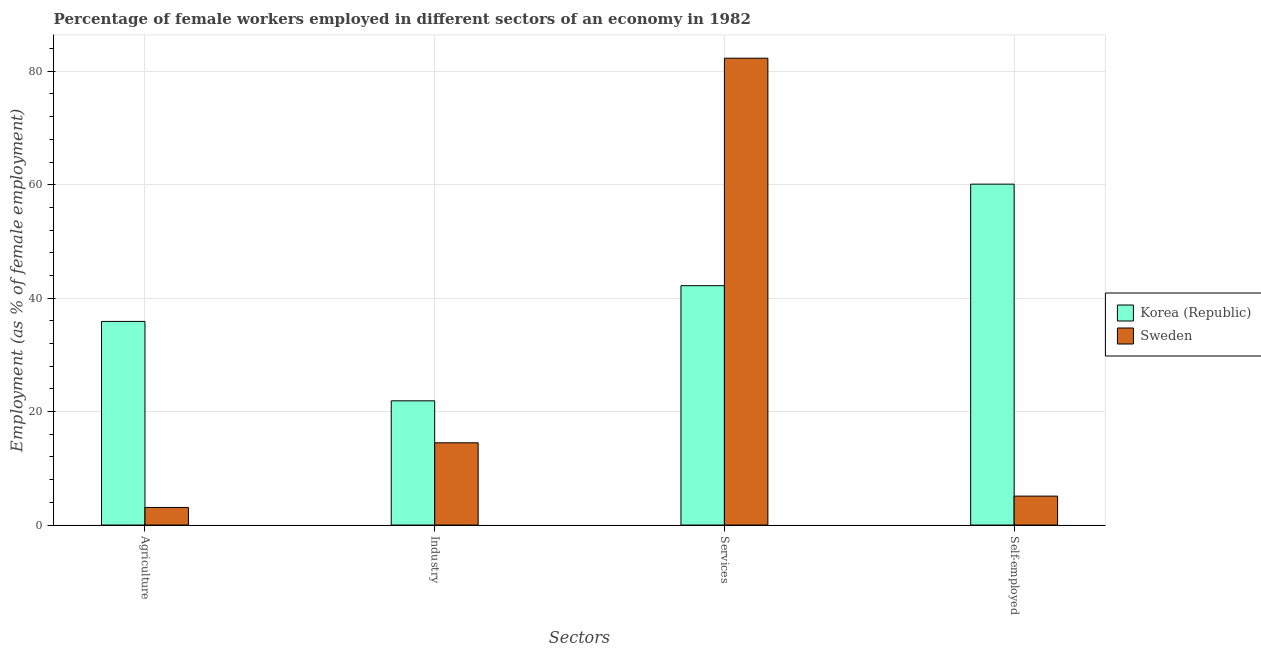How many groups of bars are there?
Provide a short and direct response. 4. Are the number of bars per tick equal to the number of legend labels?
Your answer should be very brief. Yes. Are the number of bars on each tick of the X-axis equal?
Make the answer very short. Yes. How many bars are there on the 2nd tick from the left?
Offer a terse response. 2. What is the label of the 3rd group of bars from the left?
Offer a very short reply. Services. What is the percentage of female workers in agriculture in Sweden?
Give a very brief answer. 3.1. Across all countries, what is the maximum percentage of female workers in services?
Make the answer very short. 82.3. Across all countries, what is the minimum percentage of female workers in services?
Provide a short and direct response. 42.2. What is the total percentage of female workers in services in the graph?
Offer a very short reply. 124.5. What is the difference between the percentage of female workers in industry in Sweden and that in Korea (Republic)?
Keep it short and to the point. -7.4. What is the difference between the percentage of female workers in agriculture in Sweden and the percentage of female workers in services in Korea (Republic)?
Provide a short and direct response. -39.1. What is the average percentage of self employed female workers per country?
Your answer should be very brief. 32.6. What is the difference between the percentage of female workers in services and percentage of female workers in agriculture in Sweden?
Keep it short and to the point. 79.2. What is the ratio of the percentage of female workers in industry in Sweden to that in Korea (Republic)?
Your response must be concise. 0.66. What is the difference between the highest and the second highest percentage of female workers in services?
Ensure brevity in your answer.  40.1. What is the difference between the highest and the lowest percentage of female workers in industry?
Offer a very short reply. 7.4. What does the 2nd bar from the left in Self-employed represents?
Provide a succinct answer. Sweden. Is it the case that in every country, the sum of the percentage of female workers in agriculture and percentage of female workers in industry is greater than the percentage of female workers in services?
Your answer should be very brief. No. How many bars are there?
Provide a short and direct response. 8. What is the difference between two consecutive major ticks on the Y-axis?
Give a very brief answer. 20. Does the graph contain any zero values?
Give a very brief answer. No. Where does the legend appear in the graph?
Make the answer very short. Center right. How are the legend labels stacked?
Provide a short and direct response. Vertical. What is the title of the graph?
Give a very brief answer. Percentage of female workers employed in different sectors of an economy in 1982. What is the label or title of the X-axis?
Your answer should be very brief. Sectors. What is the label or title of the Y-axis?
Offer a terse response. Employment (as % of female employment). What is the Employment (as % of female employment) in Korea (Republic) in Agriculture?
Your answer should be compact. 35.9. What is the Employment (as % of female employment) of Sweden in Agriculture?
Ensure brevity in your answer.  3.1. What is the Employment (as % of female employment) of Korea (Republic) in Industry?
Your response must be concise. 21.9. What is the Employment (as % of female employment) in Sweden in Industry?
Make the answer very short. 14.5. What is the Employment (as % of female employment) in Korea (Republic) in Services?
Keep it short and to the point. 42.2. What is the Employment (as % of female employment) in Sweden in Services?
Your answer should be compact. 82.3. What is the Employment (as % of female employment) of Korea (Republic) in Self-employed?
Offer a very short reply. 60.1. What is the Employment (as % of female employment) of Sweden in Self-employed?
Your answer should be compact. 5.1. Across all Sectors, what is the maximum Employment (as % of female employment) in Korea (Republic)?
Offer a terse response. 60.1. Across all Sectors, what is the maximum Employment (as % of female employment) in Sweden?
Provide a short and direct response. 82.3. Across all Sectors, what is the minimum Employment (as % of female employment) in Korea (Republic)?
Your answer should be compact. 21.9. Across all Sectors, what is the minimum Employment (as % of female employment) in Sweden?
Make the answer very short. 3.1. What is the total Employment (as % of female employment) in Korea (Republic) in the graph?
Your response must be concise. 160.1. What is the total Employment (as % of female employment) in Sweden in the graph?
Provide a short and direct response. 105. What is the difference between the Employment (as % of female employment) of Korea (Republic) in Agriculture and that in Industry?
Keep it short and to the point. 14. What is the difference between the Employment (as % of female employment) in Sweden in Agriculture and that in Industry?
Keep it short and to the point. -11.4. What is the difference between the Employment (as % of female employment) in Sweden in Agriculture and that in Services?
Provide a succinct answer. -79.2. What is the difference between the Employment (as % of female employment) of Korea (Republic) in Agriculture and that in Self-employed?
Offer a terse response. -24.2. What is the difference between the Employment (as % of female employment) of Sweden in Agriculture and that in Self-employed?
Provide a succinct answer. -2. What is the difference between the Employment (as % of female employment) in Korea (Republic) in Industry and that in Services?
Provide a short and direct response. -20.3. What is the difference between the Employment (as % of female employment) in Sweden in Industry and that in Services?
Make the answer very short. -67.8. What is the difference between the Employment (as % of female employment) in Korea (Republic) in Industry and that in Self-employed?
Offer a terse response. -38.2. What is the difference between the Employment (as % of female employment) of Sweden in Industry and that in Self-employed?
Your response must be concise. 9.4. What is the difference between the Employment (as % of female employment) of Korea (Republic) in Services and that in Self-employed?
Give a very brief answer. -17.9. What is the difference between the Employment (as % of female employment) in Sweden in Services and that in Self-employed?
Provide a short and direct response. 77.2. What is the difference between the Employment (as % of female employment) of Korea (Republic) in Agriculture and the Employment (as % of female employment) of Sweden in Industry?
Offer a terse response. 21.4. What is the difference between the Employment (as % of female employment) of Korea (Republic) in Agriculture and the Employment (as % of female employment) of Sweden in Services?
Provide a short and direct response. -46.4. What is the difference between the Employment (as % of female employment) of Korea (Republic) in Agriculture and the Employment (as % of female employment) of Sweden in Self-employed?
Your answer should be compact. 30.8. What is the difference between the Employment (as % of female employment) of Korea (Republic) in Industry and the Employment (as % of female employment) of Sweden in Services?
Keep it short and to the point. -60.4. What is the difference between the Employment (as % of female employment) in Korea (Republic) in Services and the Employment (as % of female employment) in Sweden in Self-employed?
Offer a terse response. 37.1. What is the average Employment (as % of female employment) of Korea (Republic) per Sectors?
Your answer should be very brief. 40.02. What is the average Employment (as % of female employment) in Sweden per Sectors?
Keep it short and to the point. 26.25. What is the difference between the Employment (as % of female employment) in Korea (Republic) and Employment (as % of female employment) in Sweden in Agriculture?
Make the answer very short. 32.8. What is the difference between the Employment (as % of female employment) in Korea (Republic) and Employment (as % of female employment) in Sweden in Industry?
Make the answer very short. 7.4. What is the difference between the Employment (as % of female employment) of Korea (Republic) and Employment (as % of female employment) of Sweden in Services?
Your answer should be compact. -40.1. What is the ratio of the Employment (as % of female employment) in Korea (Republic) in Agriculture to that in Industry?
Provide a succinct answer. 1.64. What is the ratio of the Employment (as % of female employment) in Sweden in Agriculture to that in Industry?
Your answer should be very brief. 0.21. What is the ratio of the Employment (as % of female employment) in Korea (Republic) in Agriculture to that in Services?
Provide a short and direct response. 0.85. What is the ratio of the Employment (as % of female employment) of Sweden in Agriculture to that in Services?
Your response must be concise. 0.04. What is the ratio of the Employment (as % of female employment) of Korea (Republic) in Agriculture to that in Self-employed?
Provide a succinct answer. 0.6. What is the ratio of the Employment (as % of female employment) of Sweden in Agriculture to that in Self-employed?
Ensure brevity in your answer.  0.61. What is the ratio of the Employment (as % of female employment) in Korea (Republic) in Industry to that in Services?
Give a very brief answer. 0.52. What is the ratio of the Employment (as % of female employment) of Sweden in Industry to that in Services?
Provide a succinct answer. 0.18. What is the ratio of the Employment (as % of female employment) in Korea (Republic) in Industry to that in Self-employed?
Your answer should be very brief. 0.36. What is the ratio of the Employment (as % of female employment) in Sweden in Industry to that in Self-employed?
Keep it short and to the point. 2.84. What is the ratio of the Employment (as % of female employment) of Korea (Republic) in Services to that in Self-employed?
Provide a short and direct response. 0.7. What is the ratio of the Employment (as % of female employment) of Sweden in Services to that in Self-employed?
Keep it short and to the point. 16.14. What is the difference between the highest and the second highest Employment (as % of female employment) in Sweden?
Provide a short and direct response. 67.8. What is the difference between the highest and the lowest Employment (as % of female employment) in Korea (Republic)?
Provide a short and direct response. 38.2. What is the difference between the highest and the lowest Employment (as % of female employment) in Sweden?
Keep it short and to the point. 79.2. 